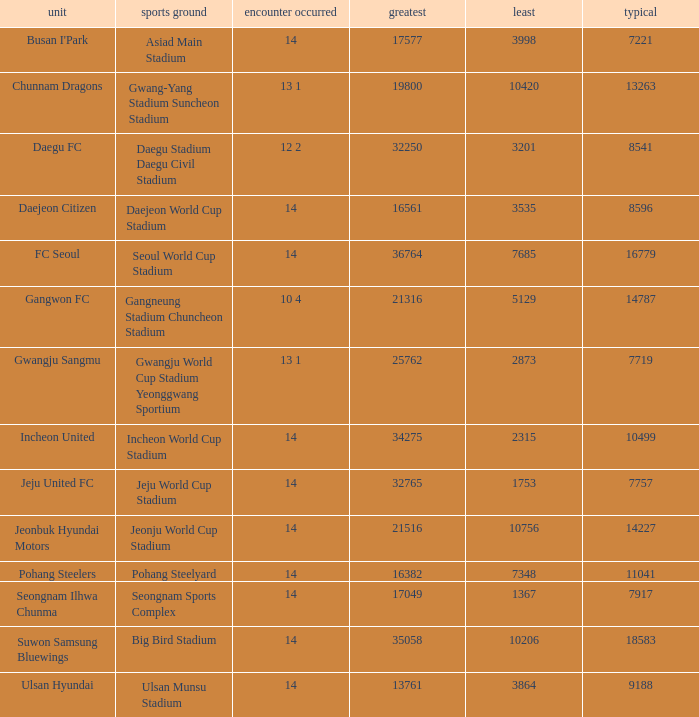Which team has 7757 as the average? Jeju United FC. 